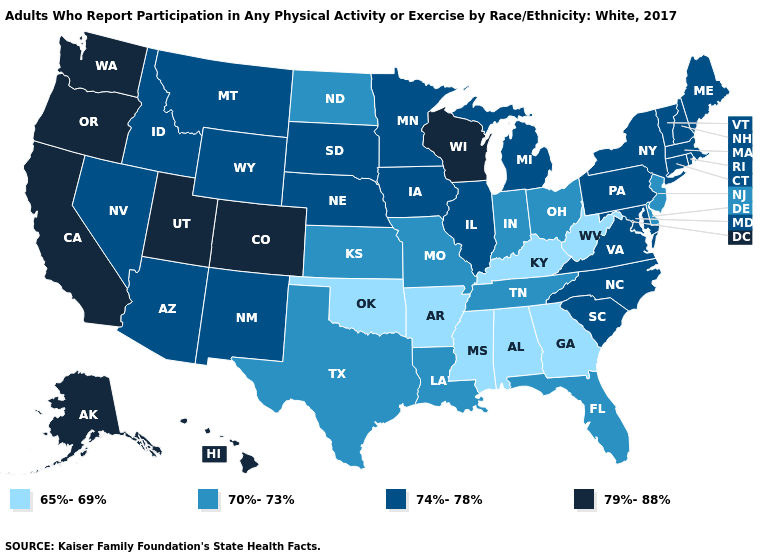Does California have the highest value in the West?
Quick response, please. Yes. Name the states that have a value in the range 70%-73%?
Answer briefly. Delaware, Florida, Indiana, Kansas, Louisiana, Missouri, New Jersey, North Dakota, Ohio, Tennessee, Texas. Which states hav the highest value in the MidWest?
Answer briefly. Wisconsin. Does Kentucky have a higher value than Mississippi?
Write a very short answer. No. What is the highest value in the USA?
Keep it brief. 79%-88%. Does New Jersey have a lower value than West Virginia?
Concise answer only. No. How many symbols are there in the legend?
Keep it brief. 4. Name the states that have a value in the range 70%-73%?
Be succinct. Delaware, Florida, Indiana, Kansas, Louisiana, Missouri, New Jersey, North Dakota, Ohio, Tennessee, Texas. Is the legend a continuous bar?
Give a very brief answer. No. What is the value of Arkansas?
Answer briefly. 65%-69%. What is the highest value in the USA?
Give a very brief answer. 79%-88%. What is the value of Arizona?
Write a very short answer. 74%-78%. Name the states that have a value in the range 65%-69%?
Answer briefly. Alabama, Arkansas, Georgia, Kentucky, Mississippi, Oklahoma, West Virginia. Does Connecticut have the highest value in the Northeast?
Be succinct. Yes. 